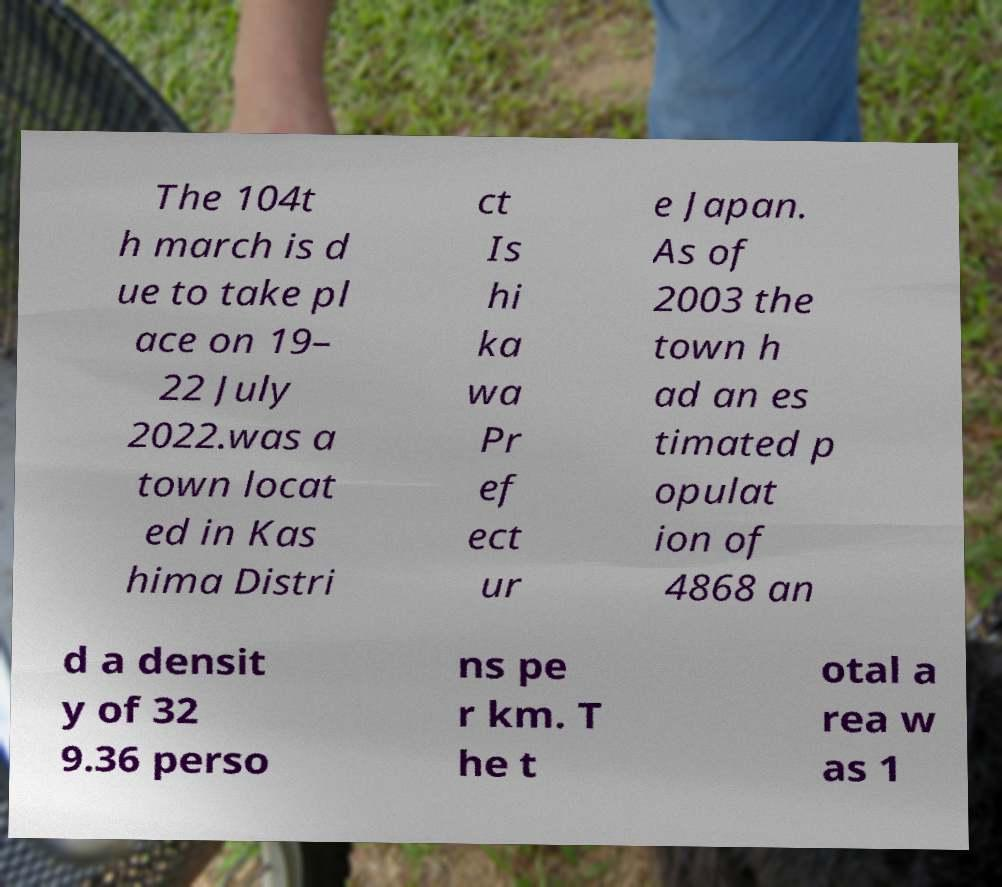For documentation purposes, I need the text within this image transcribed. Could you provide that? The 104t h march is d ue to take pl ace on 19– 22 July 2022.was a town locat ed in Kas hima Distri ct Is hi ka wa Pr ef ect ur e Japan. As of 2003 the town h ad an es timated p opulat ion of 4868 an d a densit y of 32 9.36 perso ns pe r km. T he t otal a rea w as 1 